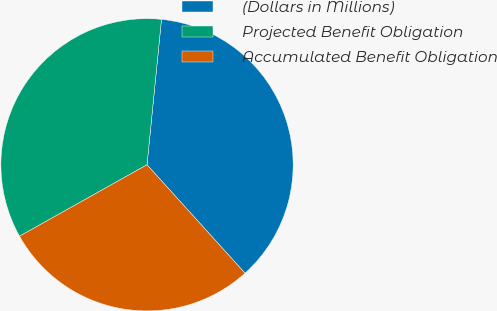<chart> <loc_0><loc_0><loc_500><loc_500><pie_chart><fcel>(Dollars in Millions)<fcel>Projected Benefit Obligation<fcel>Accumulated Benefit Obligation<nl><fcel>36.73%<fcel>34.71%<fcel>28.57%<nl></chart> 